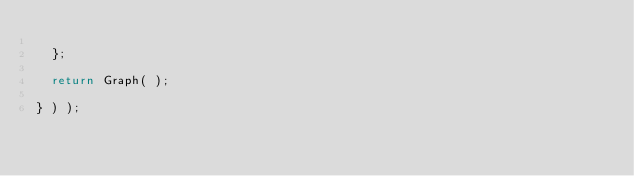Convert code to text. <code><loc_0><loc_0><loc_500><loc_500><_JavaScript_>
  };

  return Graph( );

} ) );
</code> 